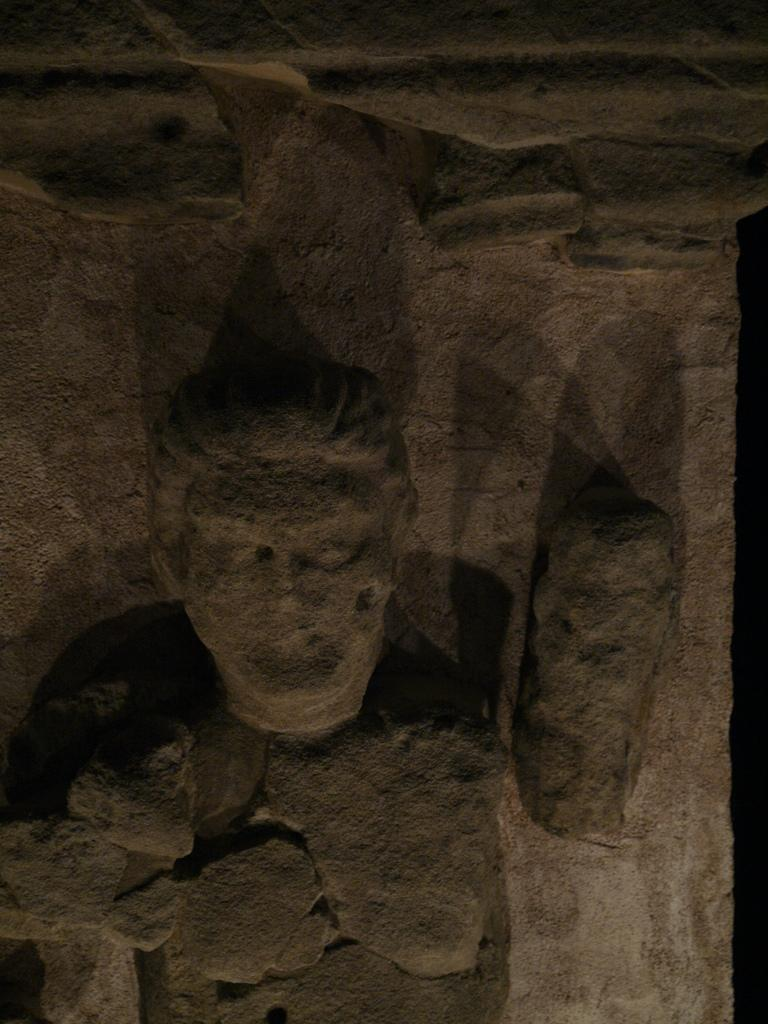What is the main subject of the image? There is a sculpture in the center of the image. What type of grass is growing on the tail of the sculpture? There is no tail or grass present on the sculpture in the image. 